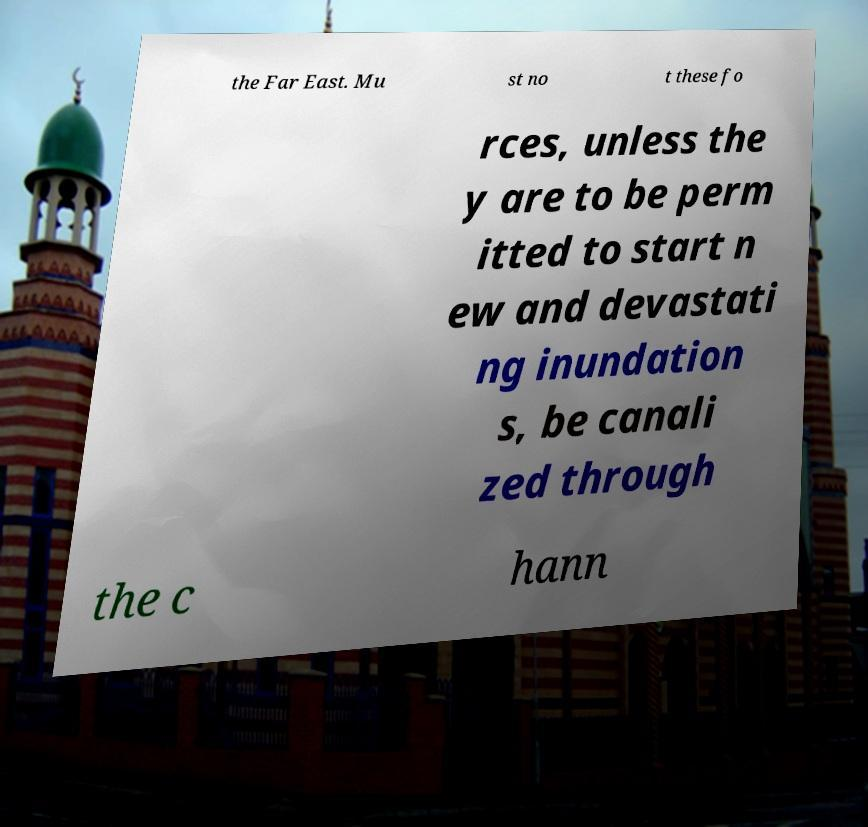I need the written content from this picture converted into text. Can you do that? the Far East. Mu st no t these fo rces, unless the y are to be perm itted to start n ew and devastati ng inundation s, be canali zed through the c hann 